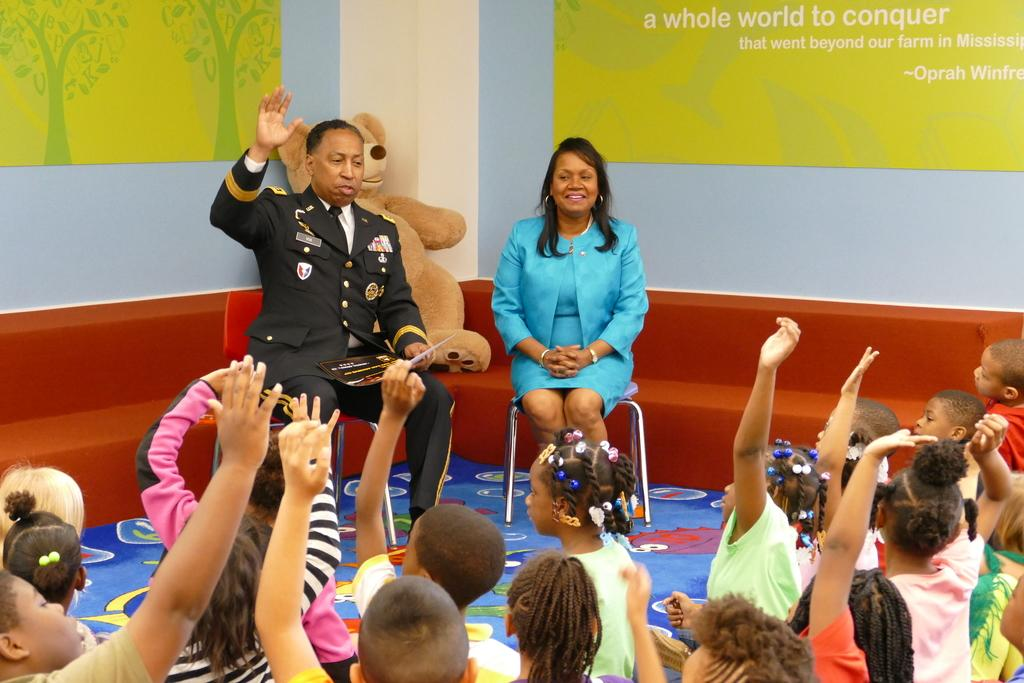What are the children in the image doing? The children are sitting on the floor and raising their hands. How many people are sitting on chairs in the image? There are two people sitting on chairs in the image. What can be seen behind the children and people? There is a brown teddy behind the children and people. What color are the posters on the wall? The posters on the wall are green. Where is the faucet located in the image? There is no faucet present in the image. What type of jelly is being used to stick the posters on the wall? There is no jelly present in the image, and the posters are not being stuck to the wall. 